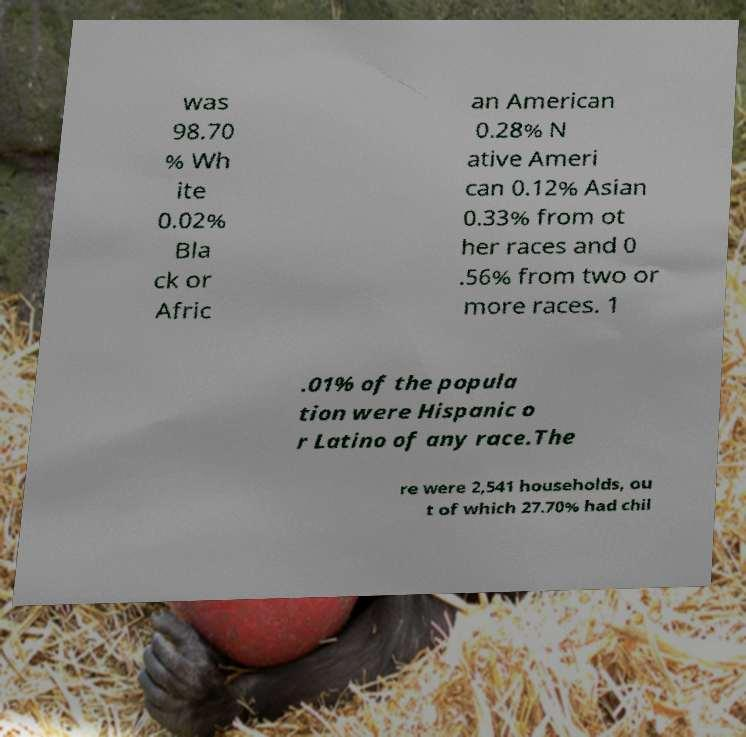There's text embedded in this image that I need extracted. Can you transcribe it verbatim? was 98.70 % Wh ite 0.02% Bla ck or Afric an American 0.28% N ative Ameri can 0.12% Asian 0.33% from ot her races and 0 .56% from two or more races. 1 .01% of the popula tion were Hispanic o r Latino of any race.The re were 2,541 households, ou t of which 27.70% had chil 